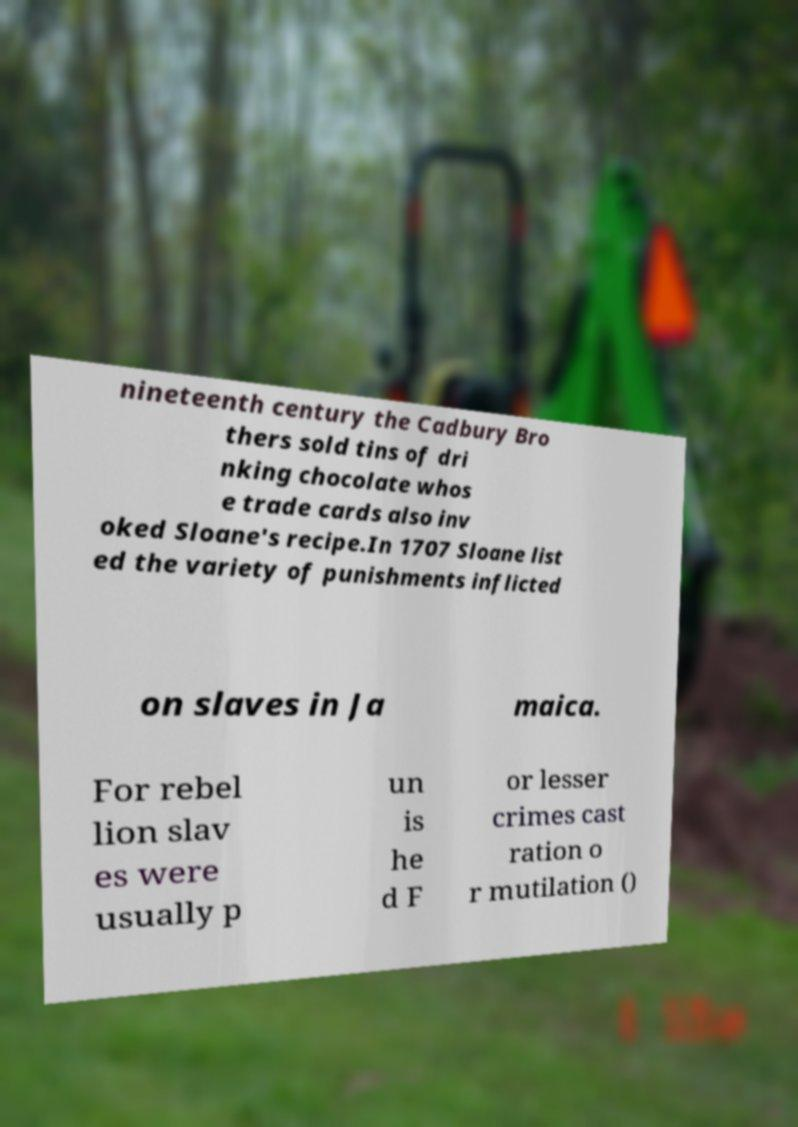For documentation purposes, I need the text within this image transcribed. Could you provide that? nineteenth century the Cadbury Bro thers sold tins of dri nking chocolate whos e trade cards also inv oked Sloane's recipe.In 1707 Sloane list ed the variety of punishments inflicted on slaves in Ja maica. For rebel lion slav es were usually p un is he d F or lesser crimes cast ration o r mutilation () 